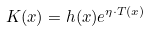Convert formula to latex. <formula><loc_0><loc_0><loc_500><loc_500>K ( x ) = h ( x ) e ^ { \eta \cdot T ( x ) }</formula> 